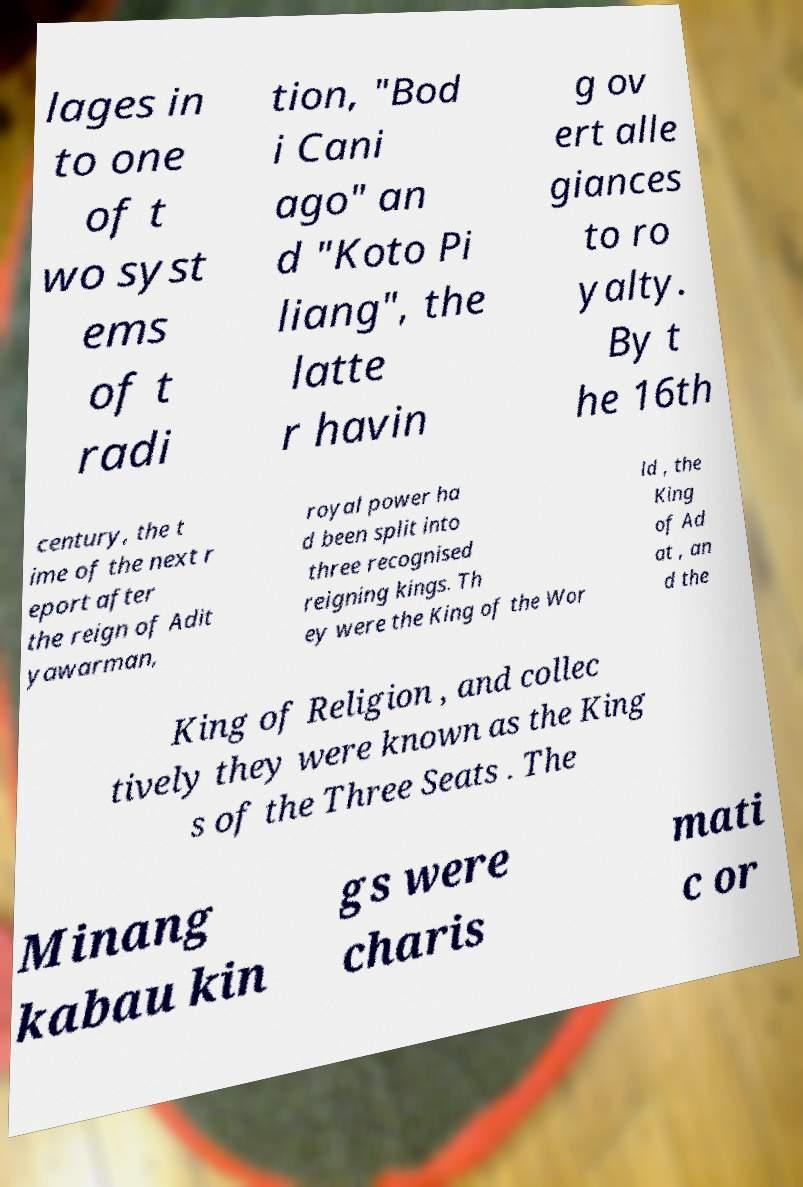I need the written content from this picture converted into text. Can you do that? lages in to one of t wo syst ems of t radi tion, "Bod i Cani ago" an d "Koto Pi liang", the latte r havin g ov ert alle giances to ro yalty. By t he 16th century, the t ime of the next r eport after the reign of Adit yawarman, royal power ha d been split into three recognised reigning kings. Th ey were the King of the Wor ld , the King of Ad at , an d the King of Religion , and collec tively they were known as the King s of the Three Seats . The Minang kabau kin gs were charis mati c or 